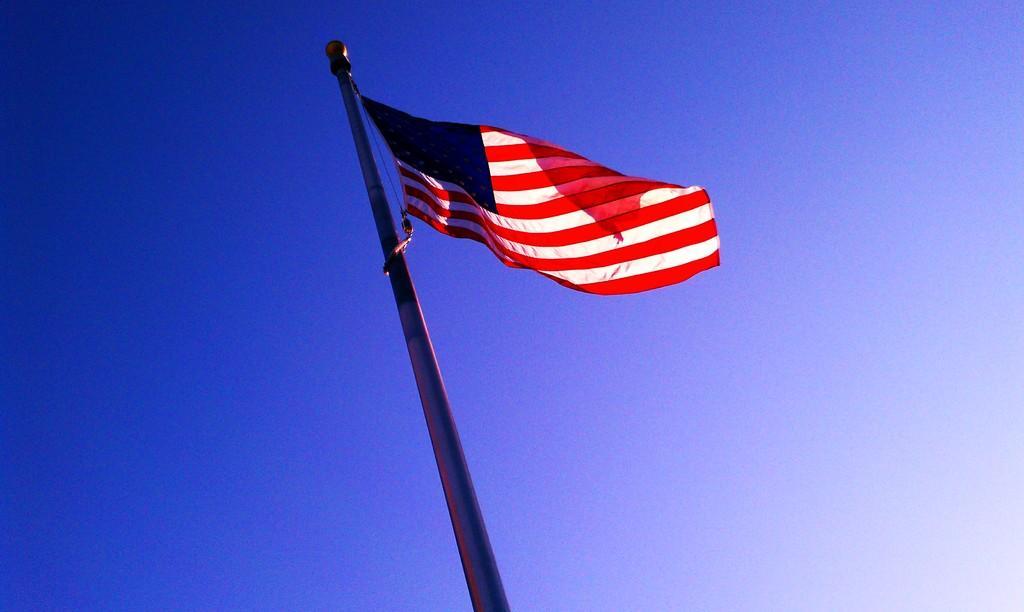Can you describe this image briefly? In this image I can see a flag attached to the pole. The flag is in white, red and blue color. Background the sky is in blue color. 